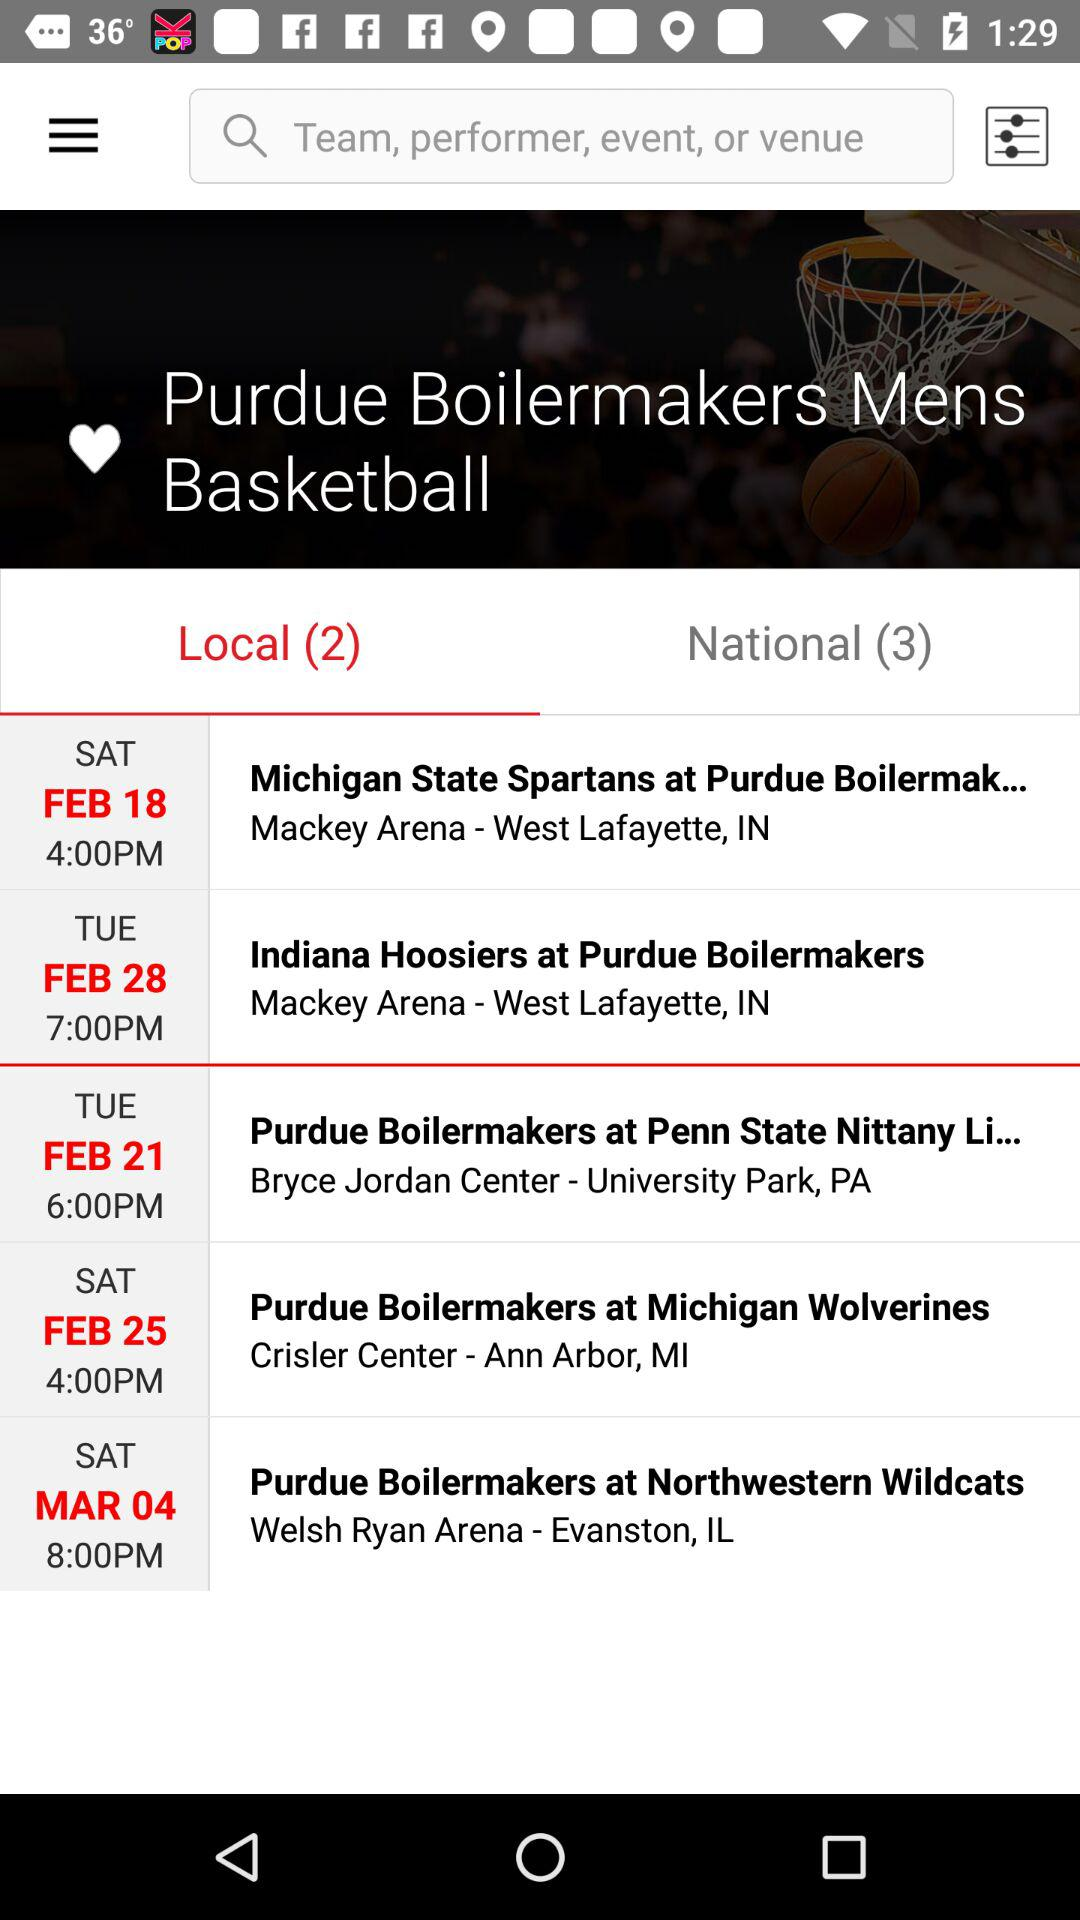What is the location of the Purdue Boilermakers at Michigan Wolverines? The location is Crisler Center - Ann Arbor, MI. 